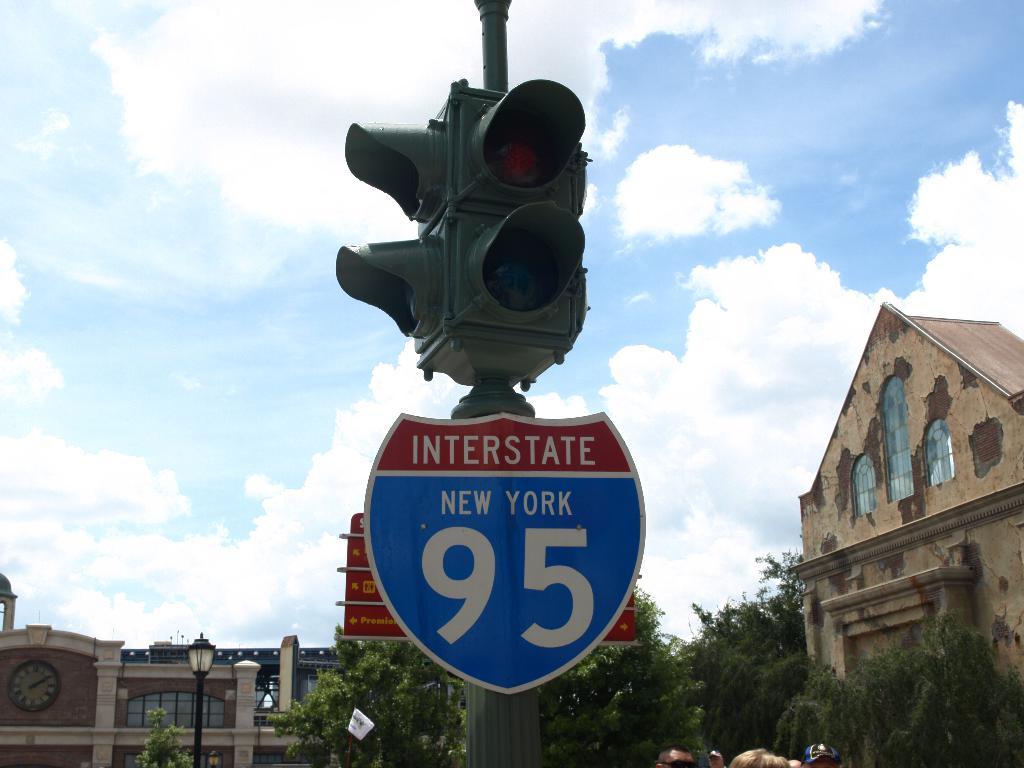Which state is this?
Your answer should be compact. New york. 